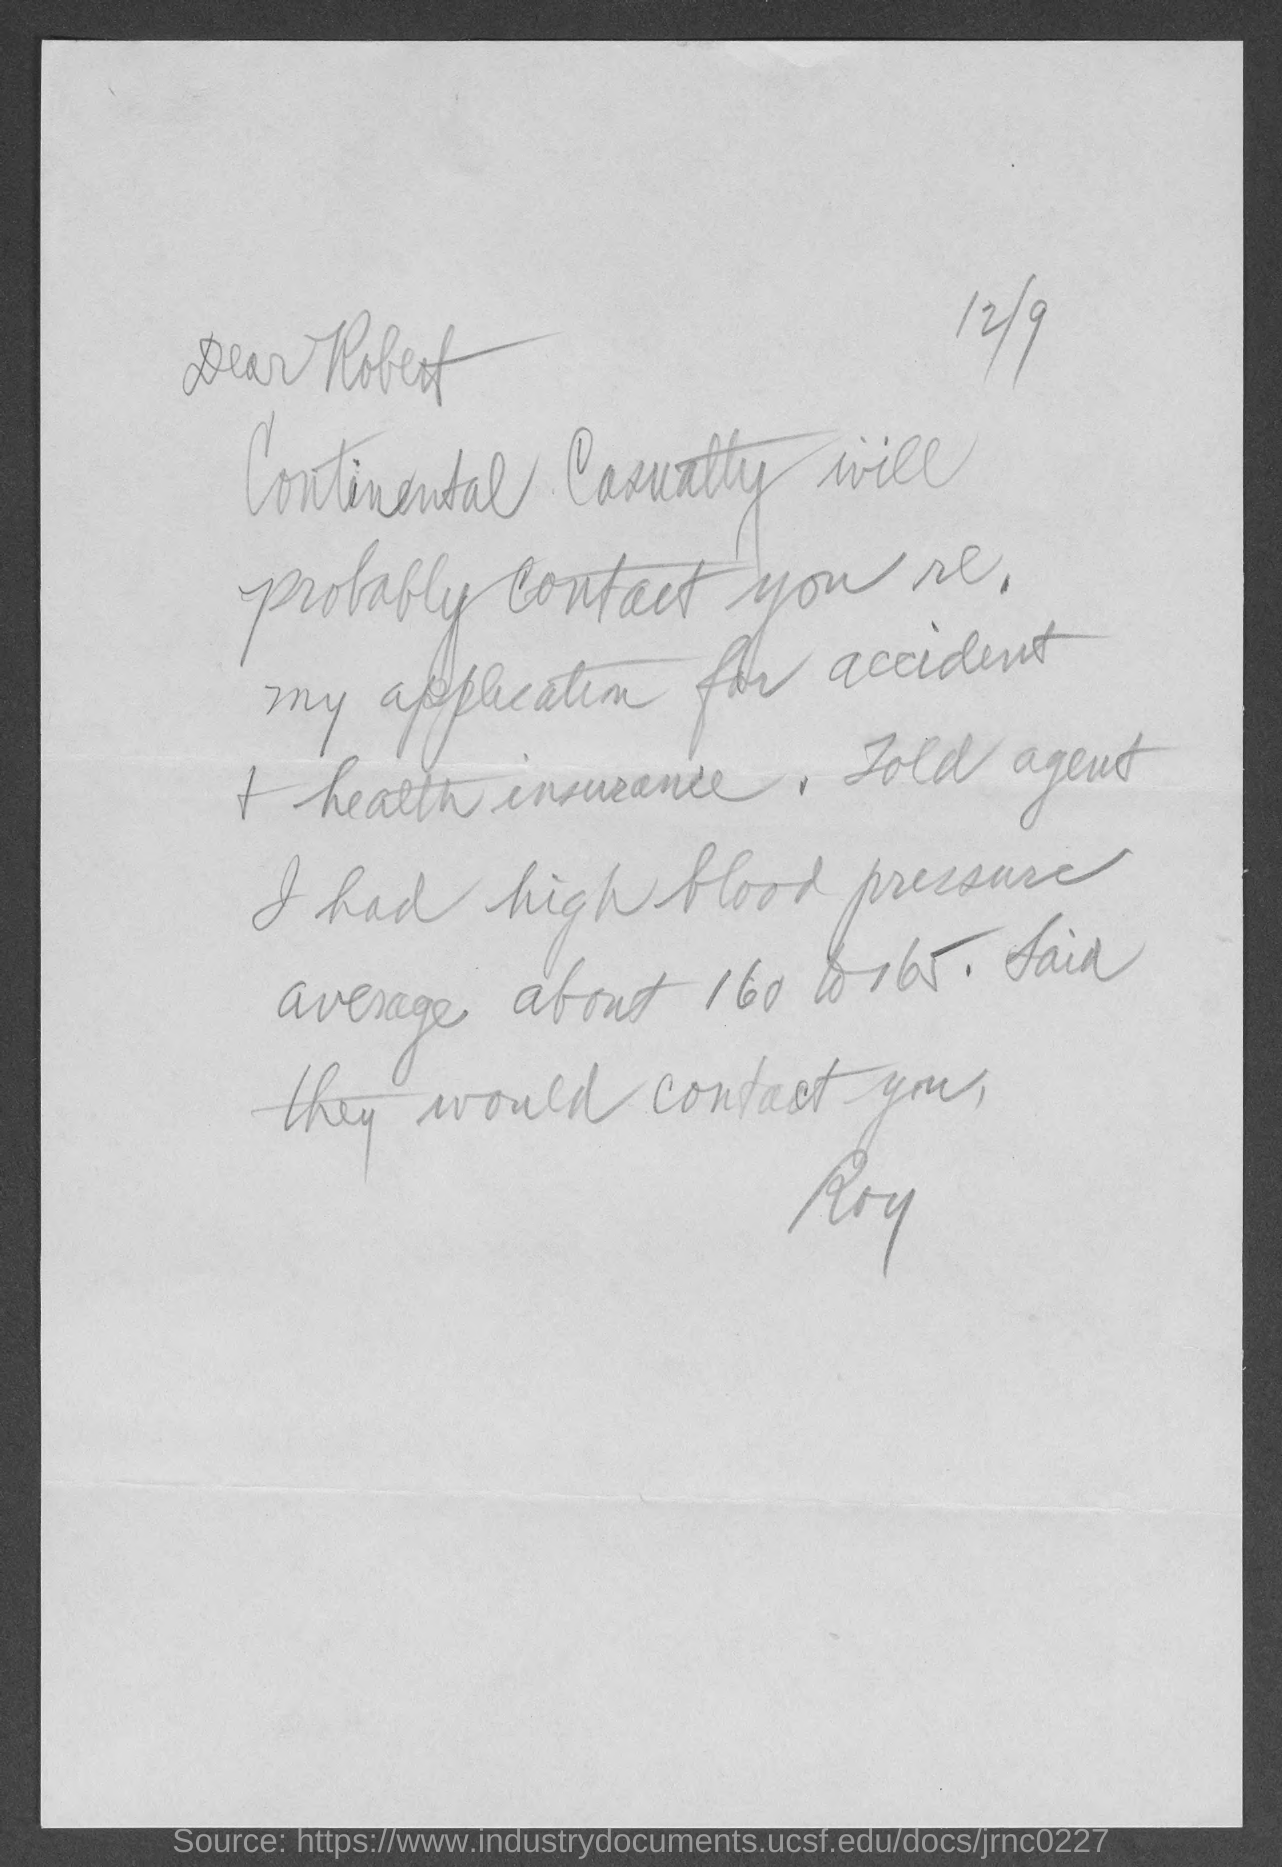What is the letter dated?
Keep it short and to the point. 12/9. To whom, the letter is addressed?
Your answer should be compact. Robert. Who is the sender of this letter?
Provide a short and direct response. Roy. 